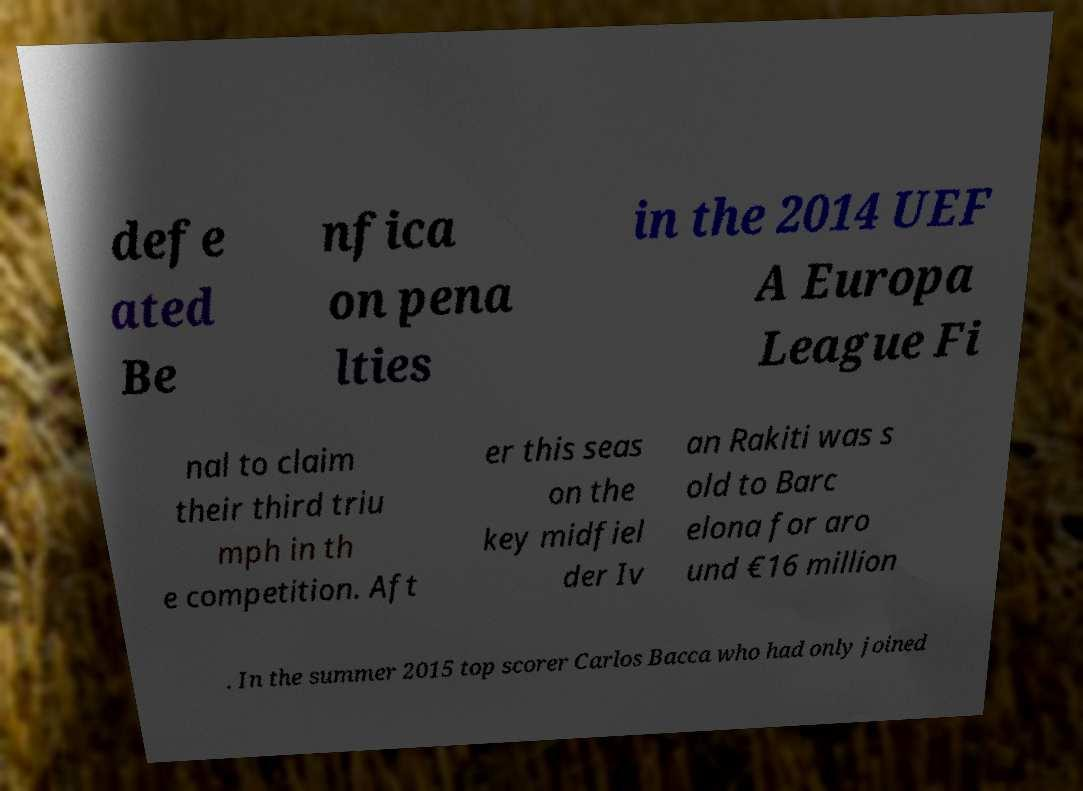Could you assist in decoding the text presented in this image and type it out clearly? defe ated Be nfica on pena lties in the 2014 UEF A Europa League Fi nal to claim their third triu mph in th e competition. Aft er this seas on the key midfiel der Iv an Rakiti was s old to Barc elona for aro und €16 million . In the summer 2015 top scorer Carlos Bacca who had only joined 